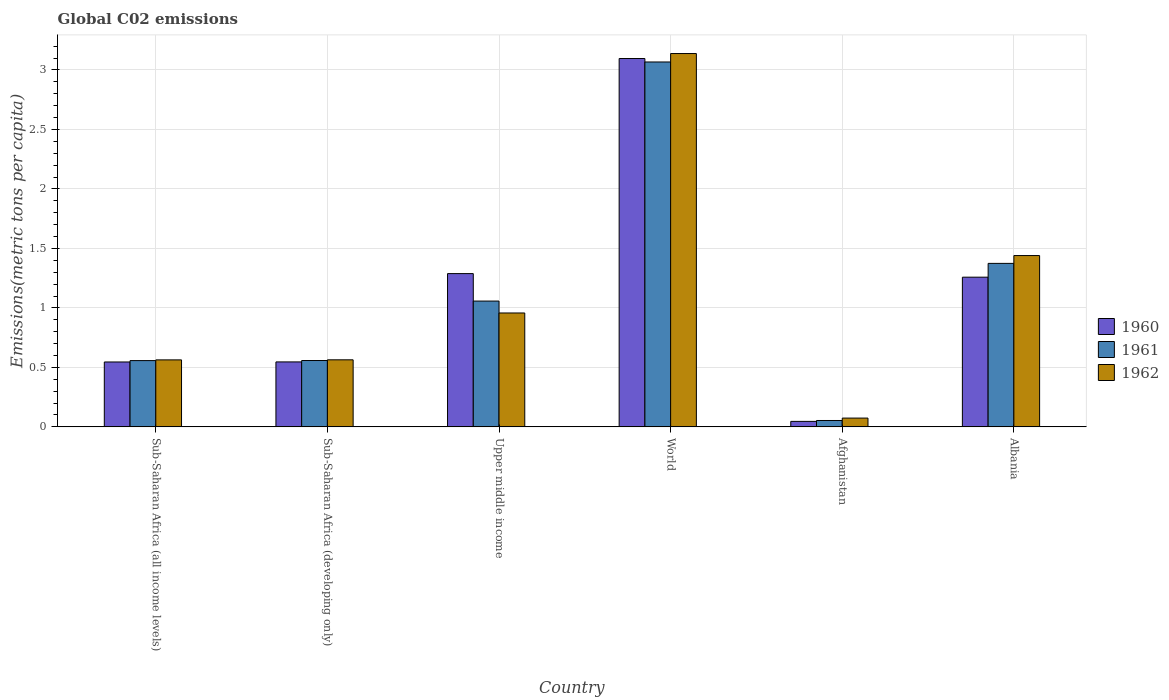Are the number of bars on each tick of the X-axis equal?
Make the answer very short. Yes. How many bars are there on the 1st tick from the left?
Provide a short and direct response. 3. How many bars are there on the 4th tick from the right?
Provide a succinct answer. 3. In how many cases, is the number of bars for a given country not equal to the number of legend labels?
Keep it short and to the point. 0. What is the amount of CO2 emitted in in 1961 in Sub-Saharan Africa (all income levels)?
Give a very brief answer. 0.56. Across all countries, what is the maximum amount of CO2 emitted in in 1960?
Your response must be concise. 3.1. Across all countries, what is the minimum amount of CO2 emitted in in 1960?
Your answer should be compact. 0.05. In which country was the amount of CO2 emitted in in 1960 minimum?
Offer a very short reply. Afghanistan. What is the total amount of CO2 emitted in in 1962 in the graph?
Your answer should be compact. 6.74. What is the difference between the amount of CO2 emitted in in 1962 in Afghanistan and that in Sub-Saharan Africa (all income levels)?
Offer a terse response. -0.49. What is the difference between the amount of CO2 emitted in in 1960 in Sub-Saharan Africa (all income levels) and the amount of CO2 emitted in in 1961 in Sub-Saharan Africa (developing only)?
Ensure brevity in your answer.  -0.01. What is the average amount of CO2 emitted in in 1962 per country?
Offer a terse response. 1.12. What is the difference between the amount of CO2 emitted in of/in 1961 and amount of CO2 emitted in of/in 1960 in Albania?
Offer a terse response. 0.12. In how many countries, is the amount of CO2 emitted in in 1962 greater than 1 metric tons per capita?
Offer a terse response. 2. What is the ratio of the amount of CO2 emitted in in 1960 in Afghanistan to that in Sub-Saharan Africa (all income levels)?
Your answer should be compact. 0.08. What is the difference between the highest and the second highest amount of CO2 emitted in in 1961?
Provide a succinct answer. -1.69. What is the difference between the highest and the lowest amount of CO2 emitted in in 1962?
Ensure brevity in your answer.  3.06. In how many countries, is the amount of CO2 emitted in in 1962 greater than the average amount of CO2 emitted in in 1962 taken over all countries?
Offer a very short reply. 2. Is the sum of the amount of CO2 emitted in in 1961 in Afghanistan and Sub-Saharan Africa (developing only) greater than the maximum amount of CO2 emitted in in 1960 across all countries?
Your answer should be compact. No. Is it the case that in every country, the sum of the amount of CO2 emitted in in 1961 and amount of CO2 emitted in in 1960 is greater than the amount of CO2 emitted in in 1962?
Your answer should be compact. Yes. How many bars are there?
Offer a terse response. 18. How many countries are there in the graph?
Your answer should be compact. 6. Are the values on the major ticks of Y-axis written in scientific E-notation?
Make the answer very short. No. Does the graph contain grids?
Ensure brevity in your answer.  Yes. What is the title of the graph?
Keep it short and to the point. Global C02 emissions. What is the label or title of the Y-axis?
Your answer should be very brief. Emissions(metric tons per capita). What is the Emissions(metric tons per capita) in 1960 in Sub-Saharan Africa (all income levels)?
Your answer should be compact. 0.55. What is the Emissions(metric tons per capita) of 1961 in Sub-Saharan Africa (all income levels)?
Keep it short and to the point. 0.56. What is the Emissions(metric tons per capita) in 1962 in Sub-Saharan Africa (all income levels)?
Your answer should be compact. 0.56. What is the Emissions(metric tons per capita) of 1960 in Sub-Saharan Africa (developing only)?
Ensure brevity in your answer.  0.55. What is the Emissions(metric tons per capita) in 1961 in Sub-Saharan Africa (developing only)?
Your answer should be very brief. 0.56. What is the Emissions(metric tons per capita) in 1962 in Sub-Saharan Africa (developing only)?
Your response must be concise. 0.56. What is the Emissions(metric tons per capita) of 1960 in Upper middle income?
Give a very brief answer. 1.29. What is the Emissions(metric tons per capita) of 1961 in Upper middle income?
Ensure brevity in your answer.  1.06. What is the Emissions(metric tons per capita) of 1962 in Upper middle income?
Your answer should be very brief. 0.96. What is the Emissions(metric tons per capita) of 1960 in World?
Your response must be concise. 3.1. What is the Emissions(metric tons per capita) of 1961 in World?
Your answer should be very brief. 3.07. What is the Emissions(metric tons per capita) in 1962 in World?
Make the answer very short. 3.14. What is the Emissions(metric tons per capita) of 1960 in Afghanistan?
Your response must be concise. 0.05. What is the Emissions(metric tons per capita) in 1961 in Afghanistan?
Keep it short and to the point. 0.05. What is the Emissions(metric tons per capita) of 1962 in Afghanistan?
Your answer should be compact. 0.07. What is the Emissions(metric tons per capita) of 1960 in Albania?
Provide a succinct answer. 1.26. What is the Emissions(metric tons per capita) of 1961 in Albania?
Keep it short and to the point. 1.37. What is the Emissions(metric tons per capita) of 1962 in Albania?
Provide a succinct answer. 1.44. Across all countries, what is the maximum Emissions(metric tons per capita) in 1960?
Offer a terse response. 3.1. Across all countries, what is the maximum Emissions(metric tons per capita) in 1961?
Ensure brevity in your answer.  3.07. Across all countries, what is the maximum Emissions(metric tons per capita) in 1962?
Your answer should be very brief. 3.14. Across all countries, what is the minimum Emissions(metric tons per capita) of 1960?
Provide a short and direct response. 0.05. Across all countries, what is the minimum Emissions(metric tons per capita) of 1961?
Provide a short and direct response. 0.05. Across all countries, what is the minimum Emissions(metric tons per capita) of 1962?
Make the answer very short. 0.07. What is the total Emissions(metric tons per capita) in 1960 in the graph?
Your answer should be compact. 6.78. What is the total Emissions(metric tons per capita) of 1961 in the graph?
Make the answer very short. 6.67. What is the total Emissions(metric tons per capita) in 1962 in the graph?
Offer a terse response. 6.74. What is the difference between the Emissions(metric tons per capita) in 1960 in Sub-Saharan Africa (all income levels) and that in Sub-Saharan Africa (developing only)?
Give a very brief answer. -0. What is the difference between the Emissions(metric tons per capita) of 1961 in Sub-Saharan Africa (all income levels) and that in Sub-Saharan Africa (developing only)?
Your response must be concise. -0. What is the difference between the Emissions(metric tons per capita) in 1962 in Sub-Saharan Africa (all income levels) and that in Sub-Saharan Africa (developing only)?
Offer a terse response. -0. What is the difference between the Emissions(metric tons per capita) in 1960 in Sub-Saharan Africa (all income levels) and that in Upper middle income?
Your response must be concise. -0.74. What is the difference between the Emissions(metric tons per capita) of 1961 in Sub-Saharan Africa (all income levels) and that in Upper middle income?
Your answer should be compact. -0.5. What is the difference between the Emissions(metric tons per capita) of 1962 in Sub-Saharan Africa (all income levels) and that in Upper middle income?
Ensure brevity in your answer.  -0.39. What is the difference between the Emissions(metric tons per capita) of 1960 in Sub-Saharan Africa (all income levels) and that in World?
Your response must be concise. -2.55. What is the difference between the Emissions(metric tons per capita) of 1961 in Sub-Saharan Africa (all income levels) and that in World?
Ensure brevity in your answer.  -2.51. What is the difference between the Emissions(metric tons per capita) of 1962 in Sub-Saharan Africa (all income levels) and that in World?
Provide a succinct answer. -2.58. What is the difference between the Emissions(metric tons per capita) of 1960 in Sub-Saharan Africa (all income levels) and that in Afghanistan?
Keep it short and to the point. 0.5. What is the difference between the Emissions(metric tons per capita) in 1961 in Sub-Saharan Africa (all income levels) and that in Afghanistan?
Your response must be concise. 0.5. What is the difference between the Emissions(metric tons per capita) of 1962 in Sub-Saharan Africa (all income levels) and that in Afghanistan?
Your answer should be compact. 0.49. What is the difference between the Emissions(metric tons per capita) of 1960 in Sub-Saharan Africa (all income levels) and that in Albania?
Keep it short and to the point. -0.71. What is the difference between the Emissions(metric tons per capita) of 1961 in Sub-Saharan Africa (all income levels) and that in Albania?
Ensure brevity in your answer.  -0.82. What is the difference between the Emissions(metric tons per capita) in 1962 in Sub-Saharan Africa (all income levels) and that in Albania?
Offer a terse response. -0.88. What is the difference between the Emissions(metric tons per capita) in 1960 in Sub-Saharan Africa (developing only) and that in Upper middle income?
Your answer should be compact. -0.74. What is the difference between the Emissions(metric tons per capita) in 1961 in Sub-Saharan Africa (developing only) and that in Upper middle income?
Offer a terse response. -0.5. What is the difference between the Emissions(metric tons per capita) of 1962 in Sub-Saharan Africa (developing only) and that in Upper middle income?
Ensure brevity in your answer.  -0.39. What is the difference between the Emissions(metric tons per capita) in 1960 in Sub-Saharan Africa (developing only) and that in World?
Offer a very short reply. -2.55. What is the difference between the Emissions(metric tons per capita) in 1961 in Sub-Saharan Africa (developing only) and that in World?
Provide a succinct answer. -2.51. What is the difference between the Emissions(metric tons per capita) in 1962 in Sub-Saharan Africa (developing only) and that in World?
Ensure brevity in your answer.  -2.57. What is the difference between the Emissions(metric tons per capita) of 1960 in Sub-Saharan Africa (developing only) and that in Afghanistan?
Your response must be concise. 0.5. What is the difference between the Emissions(metric tons per capita) of 1961 in Sub-Saharan Africa (developing only) and that in Afghanistan?
Make the answer very short. 0.5. What is the difference between the Emissions(metric tons per capita) of 1962 in Sub-Saharan Africa (developing only) and that in Afghanistan?
Your answer should be very brief. 0.49. What is the difference between the Emissions(metric tons per capita) in 1960 in Sub-Saharan Africa (developing only) and that in Albania?
Your answer should be compact. -0.71. What is the difference between the Emissions(metric tons per capita) in 1961 in Sub-Saharan Africa (developing only) and that in Albania?
Offer a very short reply. -0.82. What is the difference between the Emissions(metric tons per capita) of 1962 in Sub-Saharan Africa (developing only) and that in Albania?
Give a very brief answer. -0.88. What is the difference between the Emissions(metric tons per capita) of 1960 in Upper middle income and that in World?
Your answer should be very brief. -1.81. What is the difference between the Emissions(metric tons per capita) of 1961 in Upper middle income and that in World?
Offer a terse response. -2.01. What is the difference between the Emissions(metric tons per capita) in 1962 in Upper middle income and that in World?
Make the answer very short. -2.18. What is the difference between the Emissions(metric tons per capita) of 1960 in Upper middle income and that in Afghanistan?
Your response must be concise. 1.24. What is the difference between the Emissions(metric tons per capita) of 1962 in Upper middle income and that in Afghanistan?
Provide a succinct answer. 0.88. What is the difference between the Emissions(metric tons per capita) in 1960 in Upper middle income and that in Albania?
Keep it short and to the point. 0.03. What is the difference between the Emissions(metric tons per capita) in 1961 in Upper middle income and that in Albania?
Make the answer very short. -0.32. What is the difference between the Emissions(metric tons per capita) in 1962 in Upper middle income and that in Albania?
Offer a terse response. -0.48. What is the difference between the Emissions(metric tons per capita) in 1960 in World and that in Afghanistan?
Ensure brevity in your answer.  3.05. What is the difference between the Emissions(metric tons per capita) of 1961 in World and that in Afghanistan?
Ensure brevity in your answer.  3.01. What is the difference between the Emissions(metric tons per capita) of 1962 in World and that in Afghanistan?
Offer a very short reply. 3.06. What is the difference between the Emissions(metric tons per capita) of 1960 in World and that in Albania?
Your answer should be compact. 1.84. What is the difference between the Emissions(metric tons per capita) in 1961 in World and that in Albania?
Your answer should be very brief. 1.69. What is the difference between the Emissions(metric tons per capita) of 1962 in World and that in Albania?
Offer a very short reply. 1.7. What is the difference between the Emissions(metric tons per capita) of 1960 in Afghanistan and that in Albania?
Provide a short and direct response. -1.21. What is the difference between the Emissions(metric tons per capita) in 1961 in Afghanistan and that in Albania?
Your answer should be very brief. -1.32. What is the difference between the Emissions(metric tons per capita) in 1962 in Afghanistan and that in Albania?
Give a very brief answer. -1.37. What is the difference between the Emissions(metric tons per capita) in 1960 in Sub-Saharan Africa (all income levels) and the Emissions(metric tons per capita) in 1961 in Sub-Saharan Africa (developing only)?
Offer a very short reply. -0.01. What is the difference between the Emissions(metric tons per capita) in 1960 in Sub-Saharan Africa (all income levels) and the Emissions(metric tons per capita) in 1962 in Sub-Saharan Africa (developing only)?
Offer a very short reply. -0.02. What is the difference between the Emissions(metric tons per capita) of 1961 in Sub-Saharan Africa (all income levels) and the Emissions(metric tons per capita) of 1962 in Sub-Saharan Africa (developing only)?
Keep it short and to the point. -0.01. What is the difference between the Emissions(metric tons per capita) in 1960 in Sub-Saharan Africa (all income levels) and the Emissions(metric tons per capita) in 1961 in Upper middle income?
Provide a succinct answer. -0.51. What is the difference between the Emissions(metric tons per capita) in 1960 in Sub-Saharan Africa (all income levels) and the Emissions(metric tons per capita) in 1962 in Upper middle income?
Give a very brief answer. -0.41. What is the difference between the Emissions(metric tons per capita) in 1961 in Sub-Saharan Africa (all income levels) and the Emissions(metric tons per capita) in 1962 in Upper middle income?
Give a very brief answer. -0.4. What is the difference between the Emissions(metric tons per capita) of 1960 in Sub-Saharan Africa (all income levels) and the Emissions(metric tons per capita) of 1961 in World?
Your answer should be very brief. -2.52. What is the difference between the Emissions(metric tons per capita) of 1960 in Sub-Saharan Africa (all income levels) and the Emissions(metric tons per capita) of 1962 in World?
Provide a short and direct response. -2.59. What is the difference between the Emissions(metric tons per capita) in 1961 in Sub-Saharan Africa (all income levels) and the Emissions(metric tons per capita) in 1962 in World?
Ensure brevity in your answer.  -2.58. What is the difference between the Emissions(metric tons per capita) of 1960 in Sub-Saharan Africa (all income levels) and the Emissions(metric tons per capita) of 1961 in Afghanistan?
Your response must be concise. 0.49. What is the difference between the Emissions(metric tons per capita) in 1960 in Sub-Saharan Africa (all income levels) and the Emissions(metric tons per capita) in 1962 in Afghanistan?
Offer a terse response. 0.47. What is the difference between the Emissions(metric tons per capita) of 1961 in Sub-Saharan Africa (all income levels) and the Emissions(metric tons per capita) of 1962 in Afghanistan?
Your answer should be compact. 0.48. What is the difference between the Emissions(metric tons per capita) in 1960 in Sub-Saharan Africa (all income levels) and the Emissions(metric tons per capita) in 1961 in Albania?
Provide a succinct answer. -0.83. What is the difference between the Emissions(metric tons per capita) in 1960 in Sub-Saharan Africa (all income levels) and the Emissions(metric tons per capita) in 1962 in Albania?
Your answer should be compact. -0.89. What is the difference between the Emissions(metric tons per capita) in 1961 in Sub-Saharan Africa (all income levels) and the Emissions(metric tons per capita) in 1962 in Albania?
Provide a succinct answer. -0.88. What is the difference between the Emissions(metric tons per capita) of 1960 in Sub-Saharan Africa (developing only) and the Emissions(metric tons per capita) of 1961 in Upper middle income?
Provide a short and direct response. -0.51. What is the difference between the Emissions(metric tons per capita) in 1960 in Sub-Saharan Africa (developing only) and the Emissions(metric tons per capita) in 1962 in Upper middle income?
Your answer should be compact. -0.41. What is the difference between the Emissions(metric tons per capita) in 1961 in Sub-Saharan Africa (developing only) and the Emissions(metric tons per capita) in 1962 in Upper middle income?
Give a very brief answer. -0.4. What is the difference between the Emissions(metric tons per capita) in 1960 in Sub-Saharan Africa (developing only) and the Emissions(metric tons per capita) in 1961 in World?
Provide a succinct answer. -2.52. What is the difference between the Emissions(metric tons per capita) in 1960 in Sub-Saharan Africa (developing only) and the Emissions(metric tons per capita) in 1962 in World?
Your response must be concise. -2.59. What is the difference between the Emissions(metric tons per capita) of 1961 in Sub-Saharan Africa (developing only) and the Emissions(metric tons per capita) of 1962 in World?
Ensure brevity in your answer.  -2.58. What is the difference between the Emissions(metric tons per capita) in 1960 in Sub-Saharan Africa (developing only) and the Emissions(metric tons per capita) in 1961 in Afghanistan?
Ensure brevity in your answer.  0.49. What is the difference between the Emissions(metric tons per capita) of 1960 in Sub-Saharan Africa (developing only) and the Emissions(metric tons per capita) of 1962 in Afghanistan?
Offer a very short reply. 0.47. What is the difference between the Emissions(metric tons per capita) of 1961 in Sub-Saharan Africa (developing only) and the Emissions(metric tons per capita) of 1962 in Afghanistan?
Provide a succinct answer. 0.48. What is the difference between the Emissions(metric tons per capita) in 1960 in Sub-Saharan Africa (developing only) and the Emissions(metric tons per capita) in 1961 in Albania?
Provide a succinct answer. -0.83. What is the difference between the Emissions(metric tons per capita) in 1960 in Sub-Saharan Africa (developing only) and the Emissions(metric tons per capita) in 1962 in Albania?
Provide a succinct answer. -0.89. What is the difference between the Emissions(metric tons per capita) of 1961 in Sub-Saharan Africa (developing only) and the Emissions(metric tons per capita) of 1962 in Albania?
Ensure brevity in your answer.  -0.88. What is the difference between the Emissions(metric tons per capita) of 1960 in Upper middle income and the Emissions(metric tons per capita) of 1961 in World?
Provide a short and direct response. -1.78. What is the difference between the Emissions(metric tons per capita) in 1960 in Upper middle income and the Emissions(metric tons per capita) in 1962 in World?
Keep it short and to the point. -1.85. What is the difference between the Emissions(metric tons per capita) of 1961 in Upper middle income and the Emissions(metric tons per capita) of 1962 in World?
Provide a succinct answer. -2.08. What is the difference between the Emissions(metric tons per capita) of 1960 in Upper middle income and the Emissions(metric tons per capita) of 1961 in Afghanistan?
Offer a terse response. 1.23. What is the difference between the Emissions(metric tons per capita) of 1960 in Upper middle income and the Emissions(metric tons per capita) of 1962 in Afghanistan?
Provide a short and direct response. 1.21. What is the difference between the Emissions(metric tons per capita) of 1961 in Upper middle income and the Emissions(metric tons per capita) of 1962 in Afghanistan?
Ensure brevity in your answer.  0.98. What is the difference between the Emissions(metric tons per capita) of 1960 in Upper middle income and the Emissions(metric tons per capita) of 1961 in Albania?
Your answer should be very brief. -0.09. What is the difference between the Emissions(metric tons per capita) in 1960 in Upper middle income and the Emissions(metric tons per capita) in 1962 in Albania?
Provide a succinct answer. -0.15. What is the difference between the Emissions(metric tons per capita) in 1961 in Upper middle income and the Emissions(metric tons per capita) in 1962 in Albania?
Offer a terse response. -0.38. What is the difference between the Emissions(metric tons per capita) in 1960 in World and the Emissions(metric tons per capita) in 1961 in Afghanistan?
Provide a succinct answer. 3.04. What is the difference between the Emissions(metric tons per capita) of 1960 in World and the Emissions(metric tons per capita) of 1962 in Afghanistan?
Offer a very short reply. 3.02. What is the difference between the Emissions(metric tons per capita) in 1961 in World and the Emissions(metric tons per capita) in 1962 in Afghanistan?
Your response must be concise. 2.99. What is the difference between the Emissions(metric tons per capita) of 1960 in World and the Emissions(metric tons per capita) of 1961 in Albania?
Make the answer very short. 1.72. What is the difference between the Emissions(metric tons per capita) in 1960 in World and the Emissions(metric tons per capita) in 1962 in Albania?
Offer a terse response. 1.66. What is the difference between the Emissions(metric tons per capita) of 1961 in World and the Emissions(metric tons per capita) of 1962 in Albania?
Provide a succinct answer. 1.63. What is the difference between the Emissions(metric tons per capita) in 1960 in Afghanistan and the Emissions(metric tons per capita) in 1961 in Albania?
Offer a terse response. -1.33. What is the difference between the Emissions(metric tons per capita) of 1960 in Afghanistan and the Emissions(metric tons per capita) of 1962 in Albania?
Keep it short and to the point. -1.39. What is the difference between the Emissions(metric tons per capita) in 1961 in Afghanistan and the Emissions(metric tons per capita) in 1962 in Albania?
Provide a short and direct response. -1.39. What is the average Emissions(metric tons per capita) in 1960 per country?
Make the answer very short. 1.13. What is the average Emissions(metric tons per capita) in 1961 per country?
Provide a succinct answer. 1.11. What is the average Emissions(metric tons per capita) in 1962 per country?
Offer a very short reply. 1.12. What is the difference between the Emissions(metric tons per capita) in 1960 and Emissions(metric tons per capita) in 1961 in Sub-Saharan Africa (all income levels)?
Provide a short and direct response. -0.01. What is the difference between the Emissions(metric tons per capita) of 1960 and Emissions(metric tons per capita) of 1962 in Sub-Saharan Africa (all income levels)?
Give a very brief answer. -0.02. What is the difference between the Emissions(metric tons per capita) in 1961 and Emissions(metric tons per capita) in 1962 in Sub-Saharan Africa (all income levels)?
Keep it short and to the point. -0.01. What is the difference between the Emissions(metric tons per capita) in 1960 and Emissions(metric tons per capita) in 1961 in Sub-Saharan Africa (developing only)?
Keep it short and to the point. -0.01. What is the difference between the Emissions(metric tons per capita) of 1960 and Emissions(metric tons per capita) of 1962 in Sub-Saharan Africa (developing only)?
Make the answer very short. -0.02. What is the difference between the Emissions(metric tons per capita) in 1961 and Emissions(metric tons per capita) in 1962 in Sub-Saharan Africa (developing only)?
Make the answer very short. -0.01. What is the difference between the Emissions(metric tons per capita) of 1960 and Emissions(metric tons per capita) of 1961 in Upper middle income?
Your answer should be compact. 0.23. What is the difference between the Emissions(metric tons per capita) of 1960 and Emissions(metric tons per capita) of 1962 in Upper middle income?
Offer a very short reply. 0.33. What is the difference between the Emissions(metric tons per capita) of 1961 and Emissions(metric tons per capita) of 1962 in Upper middle income?
Provide a succinct answer. 0.1. What is the difference between the Emissions(metric tons per capita) in 1960 and Emissions(metric tons per capita) in 1961 in World?
Your response must be concise. 0.03. What is the difference between the Emissions(metric tons per capita) in 1960 and Emissions(metric tons per capita) in 1962 in World?
Provide a short and direct response. -0.04. What is the difference between the Emissions(metric tons per capita) of 1961 and Emissions(metric tons per capita) of 1962 in World?
Your answer should be very brief. -0.07. What is the difference between the Emissions(metric tons per capita) of 1960 and Emissions(metric tons per capita) of 1961 in Afghanistan?
Offer a terse response. -0.01. What is the difference between the Emissions(metric tons per capita) of 1960 and Emissions(metric tons per capita) of 1962 in Afghanistan?
Provide a succinct answer. -0.03. What is the difference between the Emissions(metric tons per capita) of 1961 and Emissions(metric tons per capita) of 1962 in Afghanistan?
Give a very brief answer. -0.02. What is the difference between the Emissions(metric tons per capita) in 1960 and Emissions(metric tons per capita) in 1961 in Albania?
Your answer should be compact. -0.12. What is the difference between the Emissions(metric tons per capita) of 1960 and Emissions(metric tons per capita) of 1962 in Albania?
Your response must be concise. -0.18. What is the difference between the Emissions(metric tons per capita) of 1961 and Emissions(metric tons per capita) of 1962 in Albania?
Your response must be concise. -0.07. What is the ratio of the Emissions(metric tons per capita) in 1962 in Sub-Saharan Africa (all income levels) to that in Sub-Saharan Africa (developing only)?
Your response must be concise. 1. What is the ratio of the Emissions(metric tons per capita) of 1960 in Sub-Saharan Africa (all income levels) to that in Upper middle income?
Provide a short and direct response. 0.42. What is the ratio of the Emissions(metric tons per capita) in 1961 in Sub-Saharan Africa (all income levels) to that in Upper middle income?
Provide a short and direct response. 0.53. What is the ratio of the Emissions(metric tons per capita) in 1962 in Sub-Saharan Africa (all income levels) to that in Upper middle income?
Your response must be concise. 0.59. What is the ratio of the Emissions(metric tons per capita) of 1960 in Sub-Saharan Africa (all income levels) to that in World?
Ensure brevity in your answer.  0.18. What is the ratio of the Emissions(metric tons per capita) in 1961 in Sub-Saharan Africa (all income levels) to that in World?
Ensure brevity in your answer.  0.18. What is the ratio of the Emissions(metric tons per capita) in 1962 in Sub-Saharan Africa (all income levels) to that in World?
Ensure brevity in your answer.  0.18. What is the ratio of the Emissions(metric tons per capita) of 1960 in Sub-Saharan Africa (all income levels) to that in Afghanistan?
Keep it short and to the point. 11.84. What is the ratio of the Emissions(metric tons per capita) in 1961 in Sub-Saharan Africa (all income levels) to that in Afghanistan?
Your answer should be compact. 10.39. What is the ratio of the Emissions(metric tons per capita) in 1962 in Sub-Saharan Africa (all income levels) to that in Afghanistan?
Keep it short and to the point. 7.63. What is the ratio of the Emissions(metric tons per capita) in 1960 in Sub-Saharan Africa (all income levels) to that in Albania?
Ensure brevity in your answer.  0.43. What is the ratio of the Emissions(metric tons per capita) in 1961 in Sub-Saharan Africa (all income levels) to that in Albania?
Keep it short and to the point. 0.41. What is the ratio of the Emissions(metric tons per capita) in 1962 in Sub-Saharan Africa (all income levels) to that in Albania?
Offer a very short reply. 0.39. What is the ratio of the Emissions(metric tons per capita) of 1960 in Sub-Saharan Africa (developing only) to that in Upper middle income?
Offer a terse response. 0.42. What is the ratio of the Emissions(metric tons per capita) in 1961 in Sub-Saharan Africa (developing only) to that in Upper middle income?
Your answer should be compact. 0.53. What is the ratio of the Emissions(metric tons per capita) in 1962 in Sub-Saharan Africa (developing only) to that in Upper middle income?
Your answer should be compact. 0.59. What is the ratio of the Emissions(metric tons per capita) in 1960 in Sub-Saharan Africa (developing only) to that in World?
Make the answer very short. 0.18. What is the ratio of the Emissions(metric tons per capita) of 1961 in Sub-Saharan Africa (developing only) to that in World?
Offer a terse response. 0.18. What is the ratio of the Emissions(metric tons per capita) in 1962 in Sub-Saharan Africa (developing only) to that in World?
Ensure brevity in your answer.  0.18. What is the ratio of the Emissions(metric tons per capita) in 1960 in Sub-Saharan Africa (developing only) to that in Afghanistan?
Provide a succinct answer. 11.85. What is the ratio of the Emissions(metric tons per capita) in 1961 in Sub-Saharan Africa (developing only) to that in Afghanistan?
Offer a terse response. 10.4. What is the ratio of the Emissions(metric tons per capita) of 1962 in Sub-Saharan Africa (developing only) to that in Afghanistan?
Your answer should be very brief. 7.64. What is the ratio of the Emissions(metric tons per capita) of 1960 in Sub-Saharan Africa (developing only) to that in Albania?
Offer a very short reply. 0.43. What is the ratio of the Emissions(metric tons per capita) of 1961 in Sub-Saharan Africa (developing only) to that in Albania?
Your answer should be very brief. 0.41. What is the ratio of the Emissions(metric tons per capita) of 1962 in Sub-Saharan Africa (developing only) to that in Albania?
Your answer should be very brief. 0.39. What is the ratio of the Emissions(metric tons per capita) in 1960 in Upper middle income to that in World?
Give a very brief answer. 0.42. What is the ratio of the Emissions(metric tons per capita) of 1961 in Upper middle income to that in World?
Give a very brief answer. 0.34. What is the ratio of the Emissions(metric tons per capita) in 1962 in Upper middle income to that in World?
Your answer should be very brief. 0.31. What is the ratio of the Emissions(metric tons per capita) in 1960 in Upper middle income to that in Afghanistan?
Offer a very short reply. 27.96. What is the ratio of the Emissions(metric tons per capita) in 1961 in Upper middle income to that in Afghanistan?
Give a very brief answer. 19.72. What is the ratio of the Emissions(metric tons per capita) in 1962 in Upper middle income to that in Afghanistan?
Give a very brief answer. 12.98. What is the ratio of the Emissions(metric tons per capita) in 1960 in Upper middle income to that in Albania?
Your response must be concise. 1.02. What is the ratio of the Emissions(metric tons per capita) in 1961 in Upper middle income to that in Albania?
Keep it short and to the point. 0.77. What is the ratio of the Emissions(metric tons per capita) of 1962 in Upper middle income to that in Albania?
Your response must be concise. 0.66. What is the ratio of the Emissions(metric tons per capita) of 1960 in World to that in Afghanistan?
Your answer should be very brief. 67.21. What is the ratio of the Emissions(metric tons per capita) of 1961 in World to that in Afghanistan?
Keep it short and to the point. 57.21. What is the ratio of the Emissions(metric tons per capita) of 1962 in World to that in Afghanistan?
Provide a succinct answer. 42.53. What is the ratio of the Emissions(metric tons per capita) in 1960 in World to that in Albania?
Ensure brevity in your answer.  2.46. What is the ratio of the Emissions(metric tons per capita) in 1961 in World to that in Albania?
Your answer should be very brief. 2.23. What is the ratio of the Emissions(metric tons per capita) in 1962 in World to that in Albania?
Provide a succinct answer. 2.18. What is the ratio of the Emissions(metric tons per capita) of 1960 in Afghanistan to that in Albania?
Give a very brief answer. 0.04. What is the ratio of the Emissions(metric tons per capita) in 1961 in Afghanistan to that in Albania?
Keep it short and to the point. 0.04. What is the ratio of the Emissions(metric tons per capita) in 1962 in Afghanistan to that in Albania?
Provide a succinct answer. 0.05. What is the difference between the highest and the second highest Emissions(metric tons per capita) of 1960?
Offer a very short reply. 1.81. What is the difference between the highest and the second highest Emissions(metric tons per capita) of 1961?
Keep it short and to the point. 1.69. What is the difference between the highest and the second highest Emissions(metric tons per capita) of 1962?
Give a very brief answer. 1.7. What is the difference between the highest and the lowest Emissions(metric tons per capita) of 1960?
Offer a very short reply. 3.05. What is the difference between the highest and the lowest Emissions(metric tons per capita) of 1961?
Give a very brief answer. 3.01. What is the difference between the highest and the lowest Emissions(metric tons per capita) of 1962?
Provide a succinct answer. 3.06. 